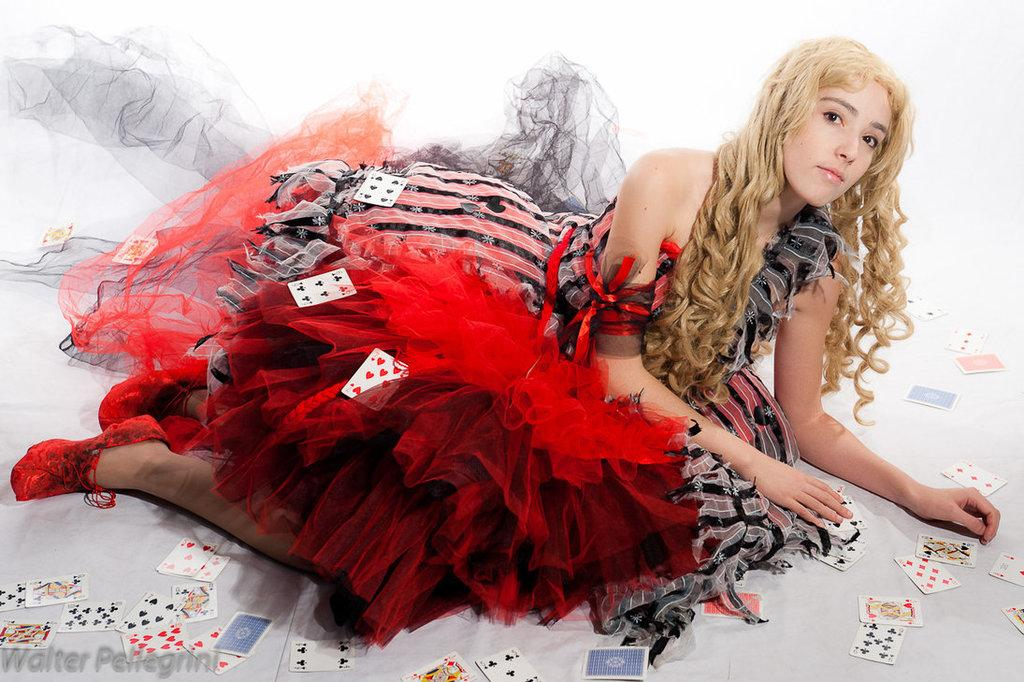Who is the main subject in the image? There is a girl in the image. What is the girl wearing? The girl is wearing a red frock. What else can be seen in the image besides the girl? There are cards on a white surface in the image. What type of skin can be seen on the cactus in the image? There is no cactus present in the image; it features a girl and cards on a white surface. 